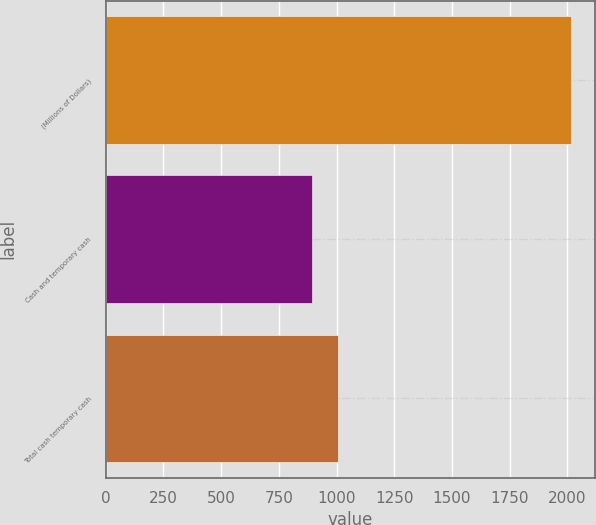Convert chart. <chart><loc_0><loc_0><loc_500><loc_500><bar_chart><fcel>(Millions of Dollars)<fcel>Cash and temporary cash<fcel>Total cash temporary cash<nl><fcel>2018<fcel>895<fcel>1007.3<nl></chart> 